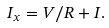<formula> <loc_0><loc_0><loc_500><loc_500>I _ { x } = V / R + I .</formula> 